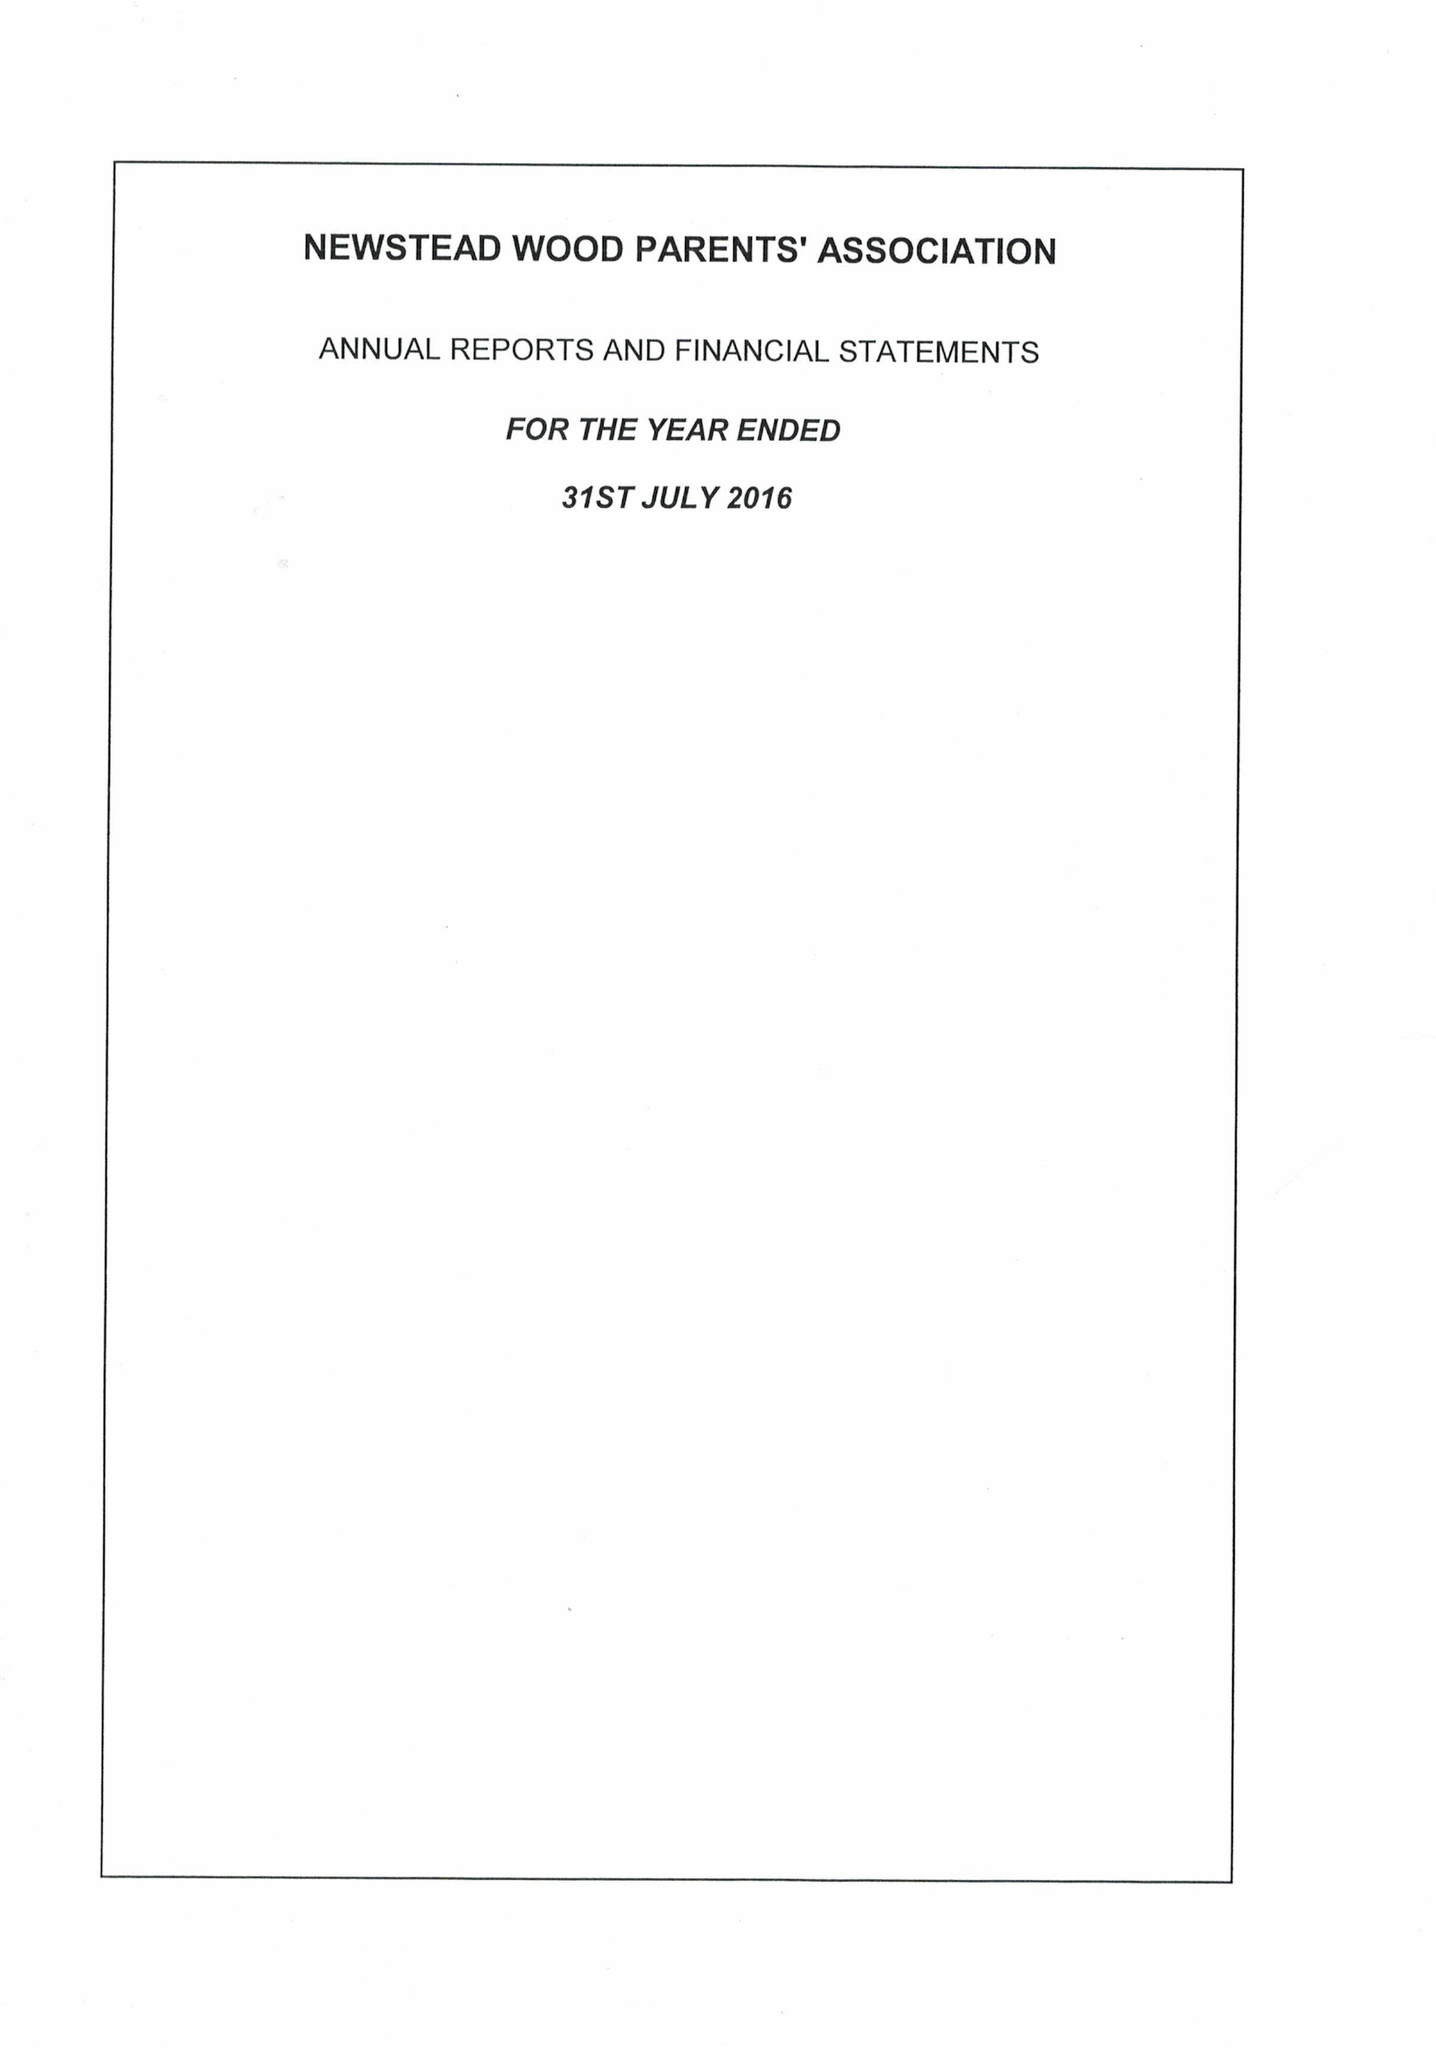What is the value for the address__postcode?
Answer the question using a single word or phrase. BR7 5RB 